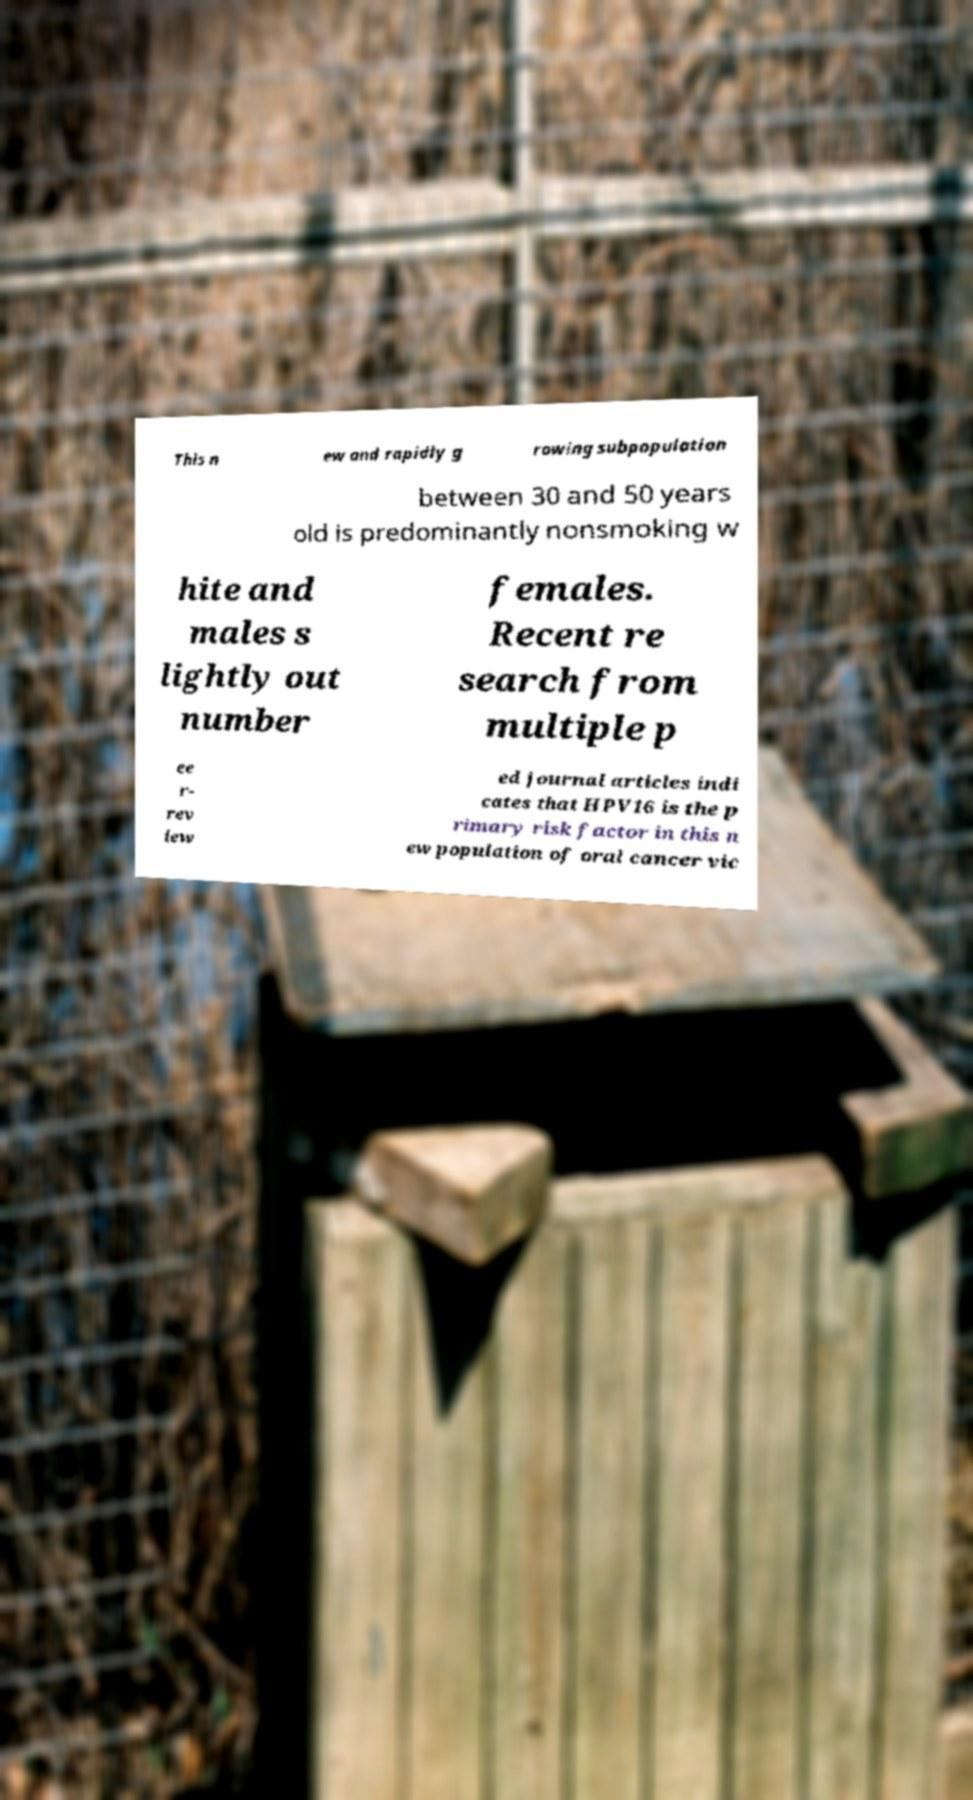Please read and relay the text visible in this image. What does it say? This n ew and rapidly g rowing subpopulation between 30 and 50 years old is predominantly nonsmoking w hite and males s lightly out number females. Recent re search from multiple p ee r- rev iew ed journal articles indi cates that HPV16 is the p rimary risk factor in this n ew population of oral cancer vic 